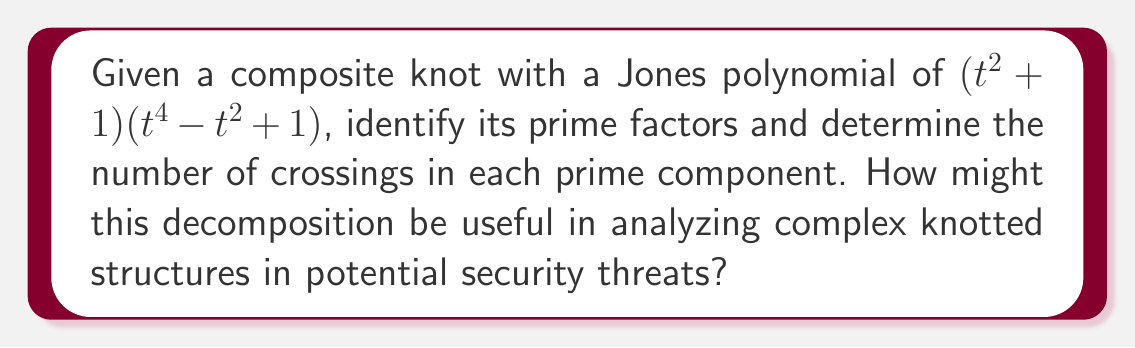Could you help me with this problem? 1) First, we need to understand that the Jones polynomial of a composite knot is the product of the Jones polynomials of its prime factors.

2) The given Jones polynomial is: $$(t^2 + 1)(t^4 - t^2 + 1)$$

3) This polynomial is already factored into two parts:
   a) $$(t^2 + 1)$$
   b) $$(t^4 - t^2 + 1)$$

4) Let's identify each factor:
   a) $(t^2 + 1)$ is the Jones polynomial of the Hopf link
   b) $(t^4 - t^2 + 1)$ is the Jones polynomial of the trefoil knot

5) To determine the number of crossings:
   a) The Hopf link has 2 crossings
   b) The trefoil knot has 3 crossings

6) In the context of analyzing security threats:
   - This decomposition allows us to break down complex knotted structures into simpler, known components.
   - Each prime factor represents a fundamental "building block" of the overall structure.
   - By identifying these basic components, we can better understand the construction and potential vulnerabilities of the complex structure.
   - This method can be applied to analyze encrypted messages, network topologies, or physical security systems that might use knot-like structures.
Answer: Hopf link (2 crossings) and trefoil knot (3 crossings) 